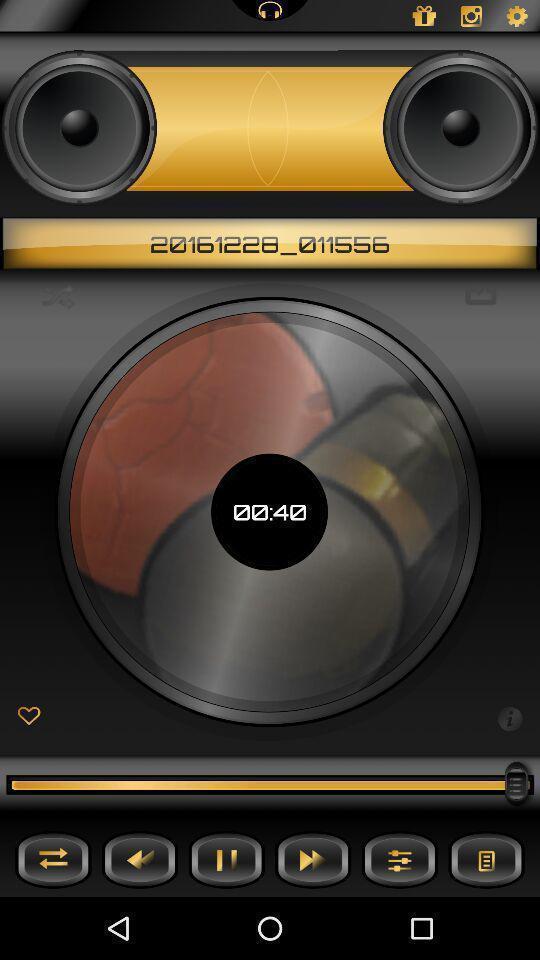Tell me about the visual elements in this screen capture. Page displaying with different options in music application. 